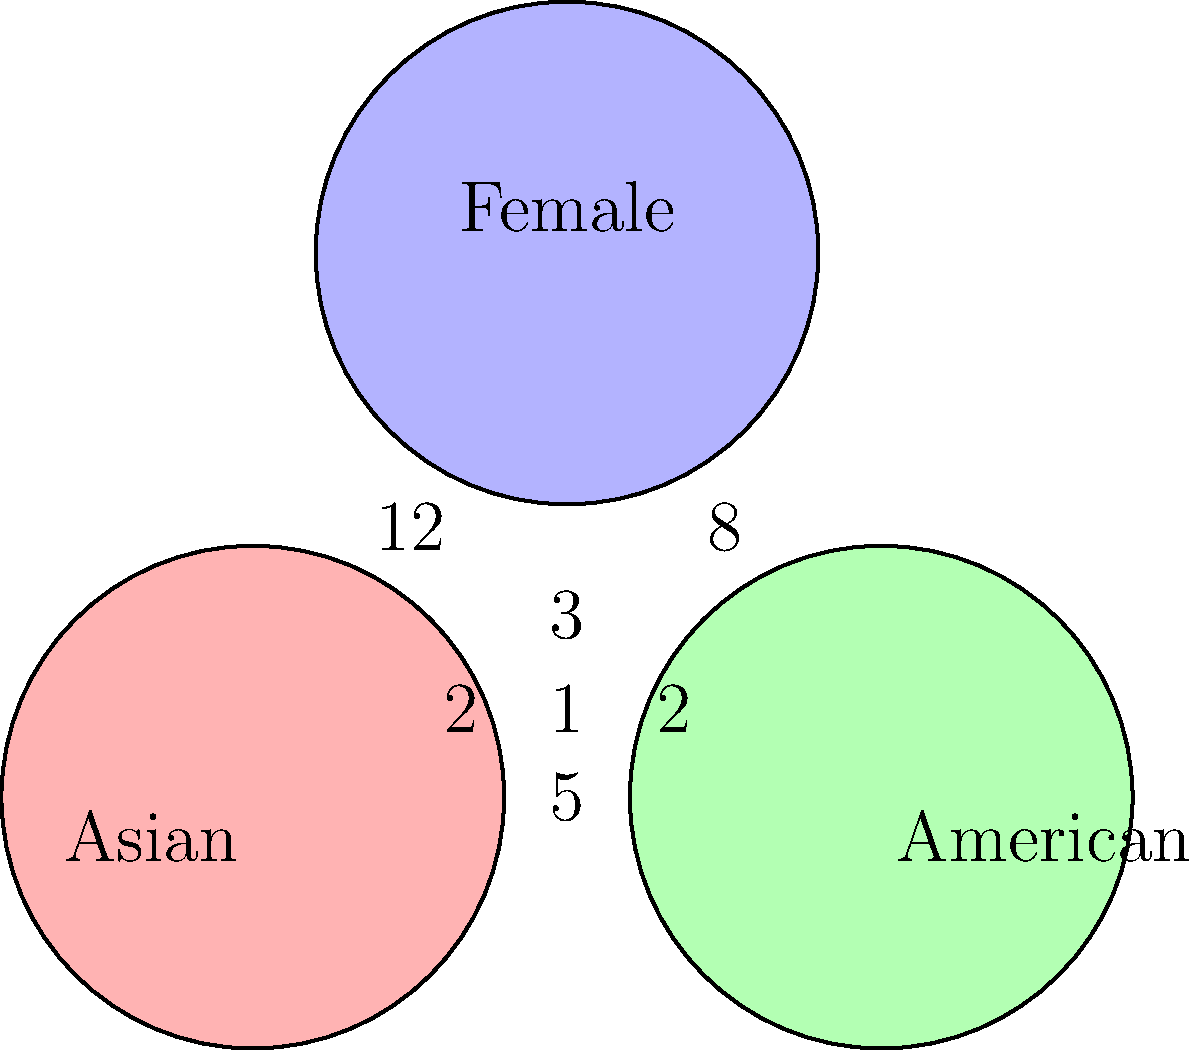Based on the Venn diagram showing the overlap between Asian, American, and female composers, how many composers are both Asian and female but not American? To solve this question, we need to follow these steps:

1. Identify the region that represents composers who are both Asian and female but not American.
2. This region is the overlap between the "Asian" and "Female" circles, excluding the area that also overlaps with the "American" circle.
3. In the Venn diagram, we can see that this region is labeled with the number 12.

Therefore, there are 12 composers who are both Asian and female but not American.

This information could be particularly relevant to the persona of an Asian-American female composer, as it provides insight into the representation of composers with similar backgrounds in the industry.
Answer: 12 